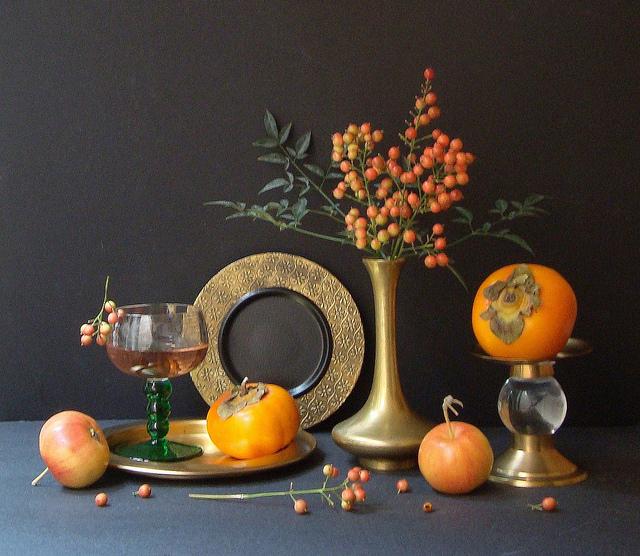How many apples are in the picture?
Be succinct. 2. How many persimmons are in the display?
Give a very brief answer. 4. Is there anything in the glass?
Quick response, please. Yes. 